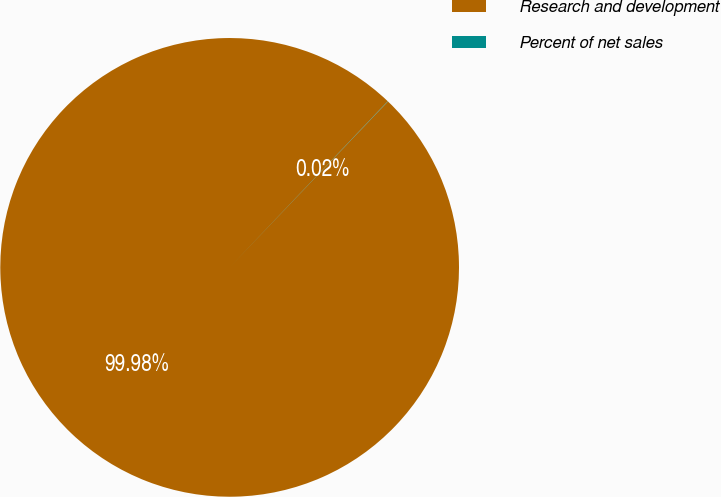Convert chart to OTSL. <chart><loc_0><loc_0><loc_500><loc_500><pie_chart><fcel>Research and development<fcel>Percent of net sales<nl><fcel>99.98%<fcel>0.02%<nl></chart> 